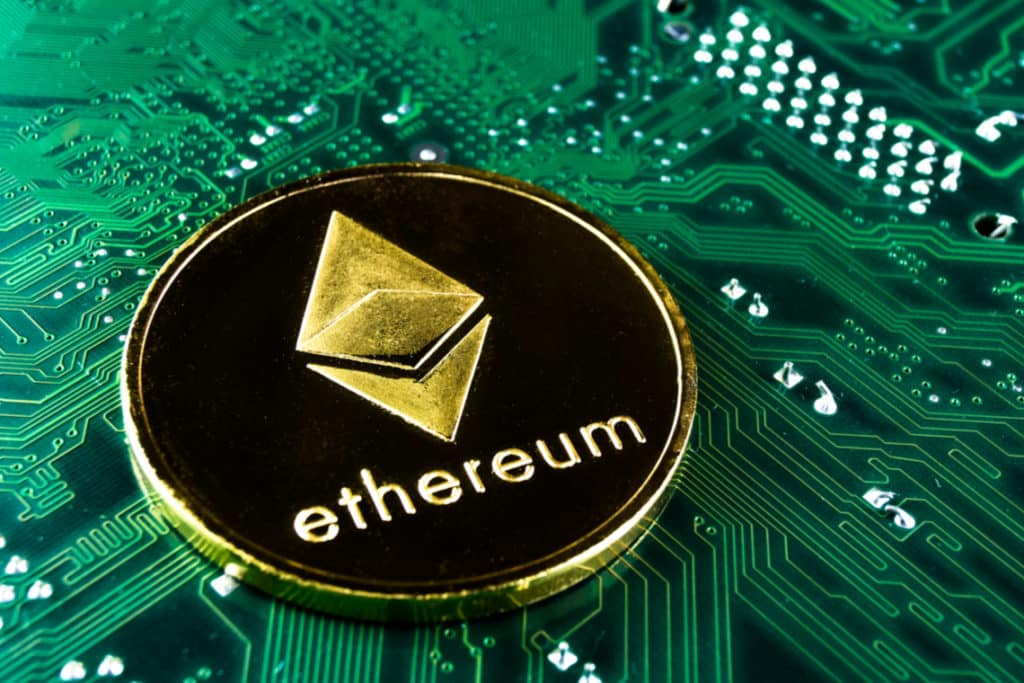What could be an alternate symbolic meaning of having a coin on a circuit board? An alternate symbolic meaning of placing an Ethereum coin on a circuit board could be the representation of value creation in the digital age. The coin stands for economic value, commonly associated with traditional finance, whereas the circuit board represents technological innovation and digital infrastructure. Combining these elements could signify the merging of traditional financial systems with modern technological advancements, illustrating how digital technologies are redefining value creation, storage, and transfer in today's economy. 